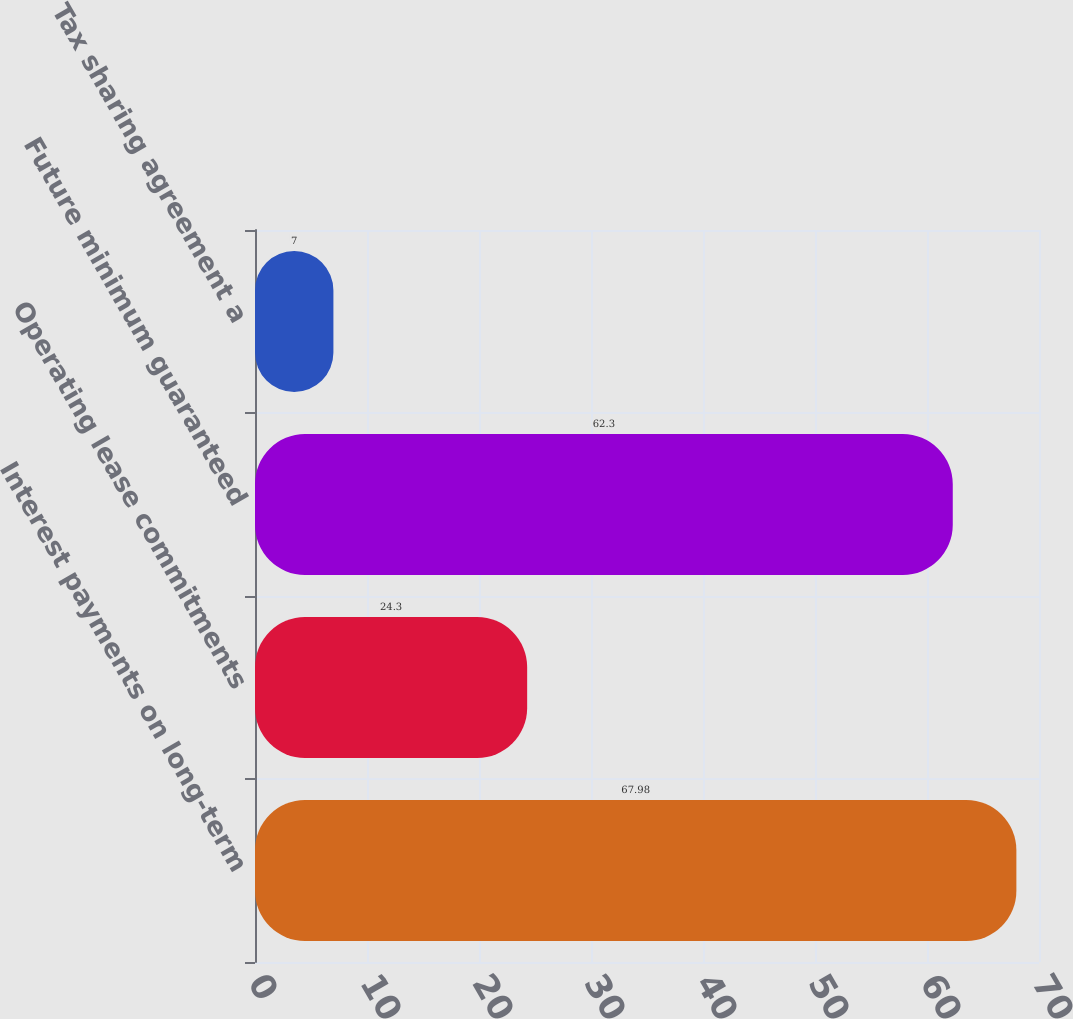<chart> <loc_0><loc_0><loc_500><loc_500><bar_chart><fcel>Interest payments on long-term<fcel>Operating lease commitments<fcel>Future minimum guaranteed<fcel>Tax sharing agreement a<nl><fcel>67.98<fcel>24.3<fcel>62.3<fcel>7<nl></chart> 